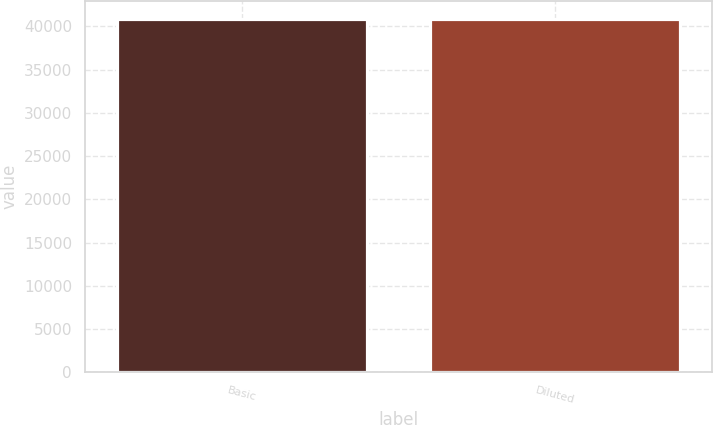Convert chart. <chart><loc_0><loc_0><loc_500><loc_500><bar_chart><fcel>Basic<fcel>Diluted<nl><fcel>40859<fcel>40859.1<nl></chart> 